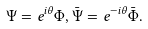Convert formula to latex. <formula><loc_0><loc_0><loc_500><loc_500>\Psi & = e ^ { i \theta } \Phi , { \bar { \Psi } } = e ^ { - i \theta } { \bar { \Phi } } .</formula> 